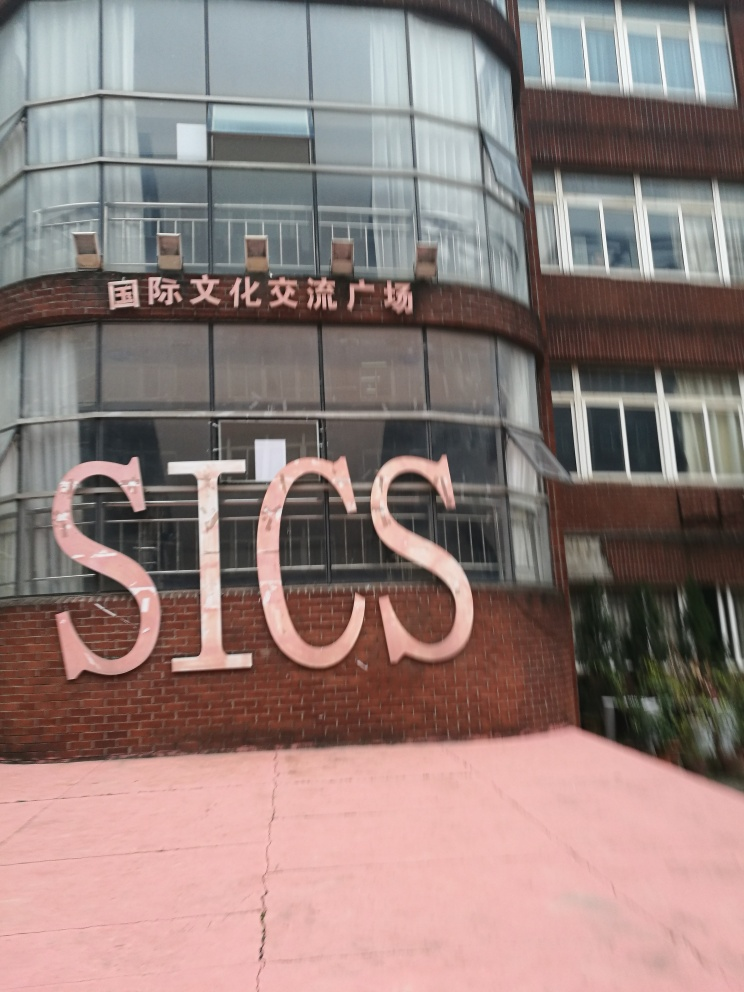Can you tell me what the letters on the building stand for? The letters 'SICS' could be an acronym for an organization, company, or institution. However, without additional context, it's not possible to determine their exact meaning. 